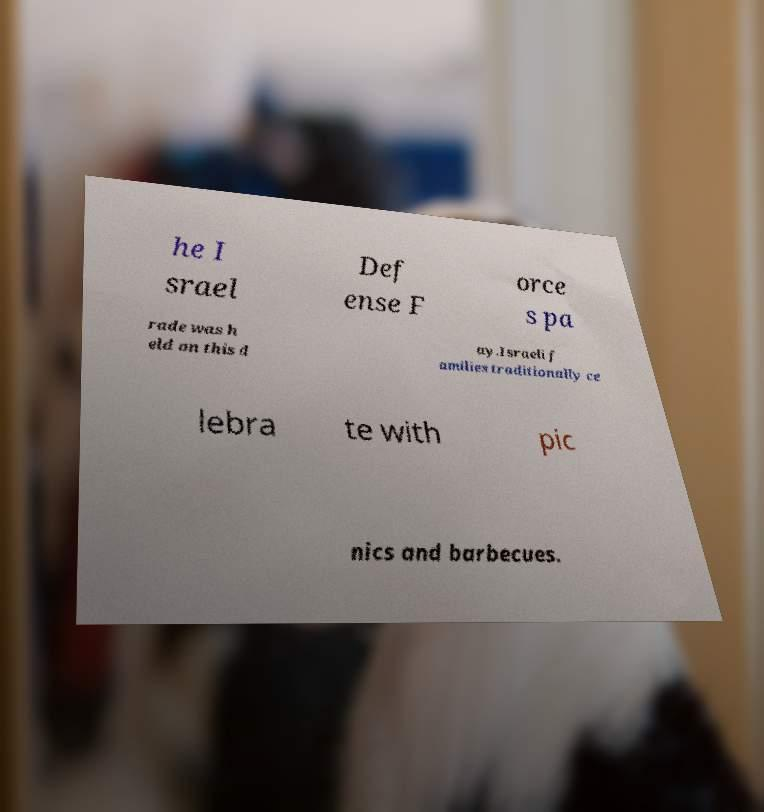Please identify and transcribe the text found in this image. he I srael Def ense F orce s pa rade was h eld on this d ay.Israeli f amilies traditionally ce lebra te with pic nics and barbecues. 